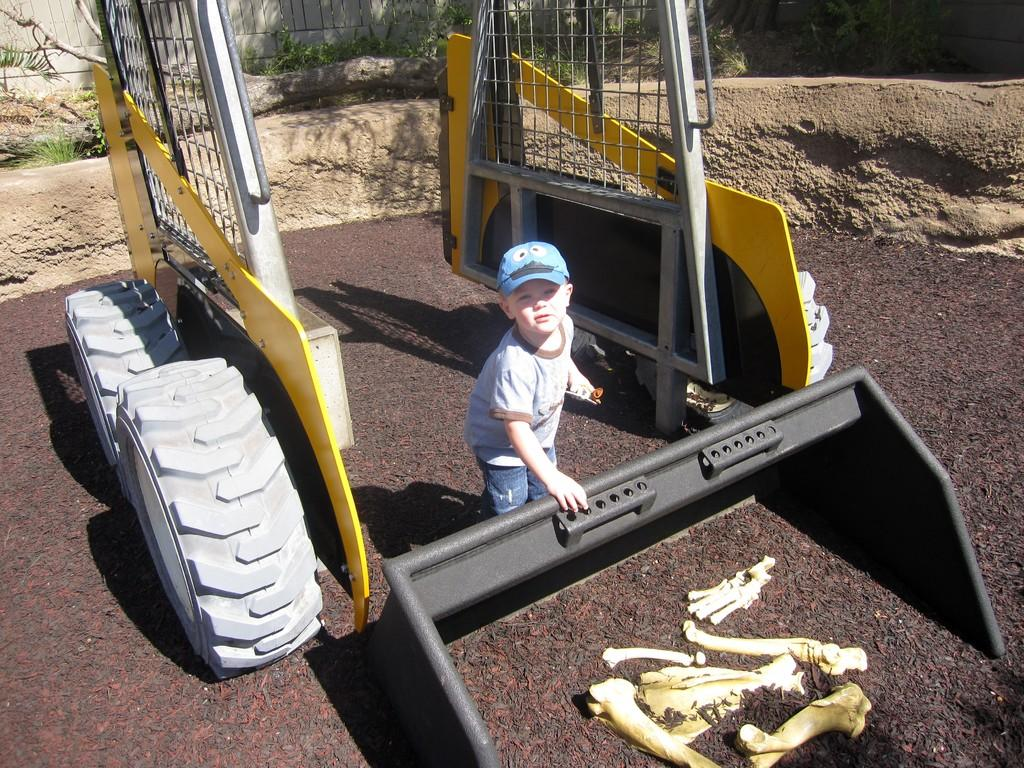What is the main subject of the image? The main subject of the image is a little boy. What is the boy wearing? The boy is wearing a t-shirt, trousers, and a cap. What is the boy holding in the image? The boy is holding a plastic JCB-shaped object. What can be seen at the bottom of the image? There are bones visible at the bottom of the image. What is the boy's opinion on the current state of the industry in the image? The image does not provide any information about the boy's opinion on the current state of the industry, as it is focused on the boy's appearance and what he is holding. 